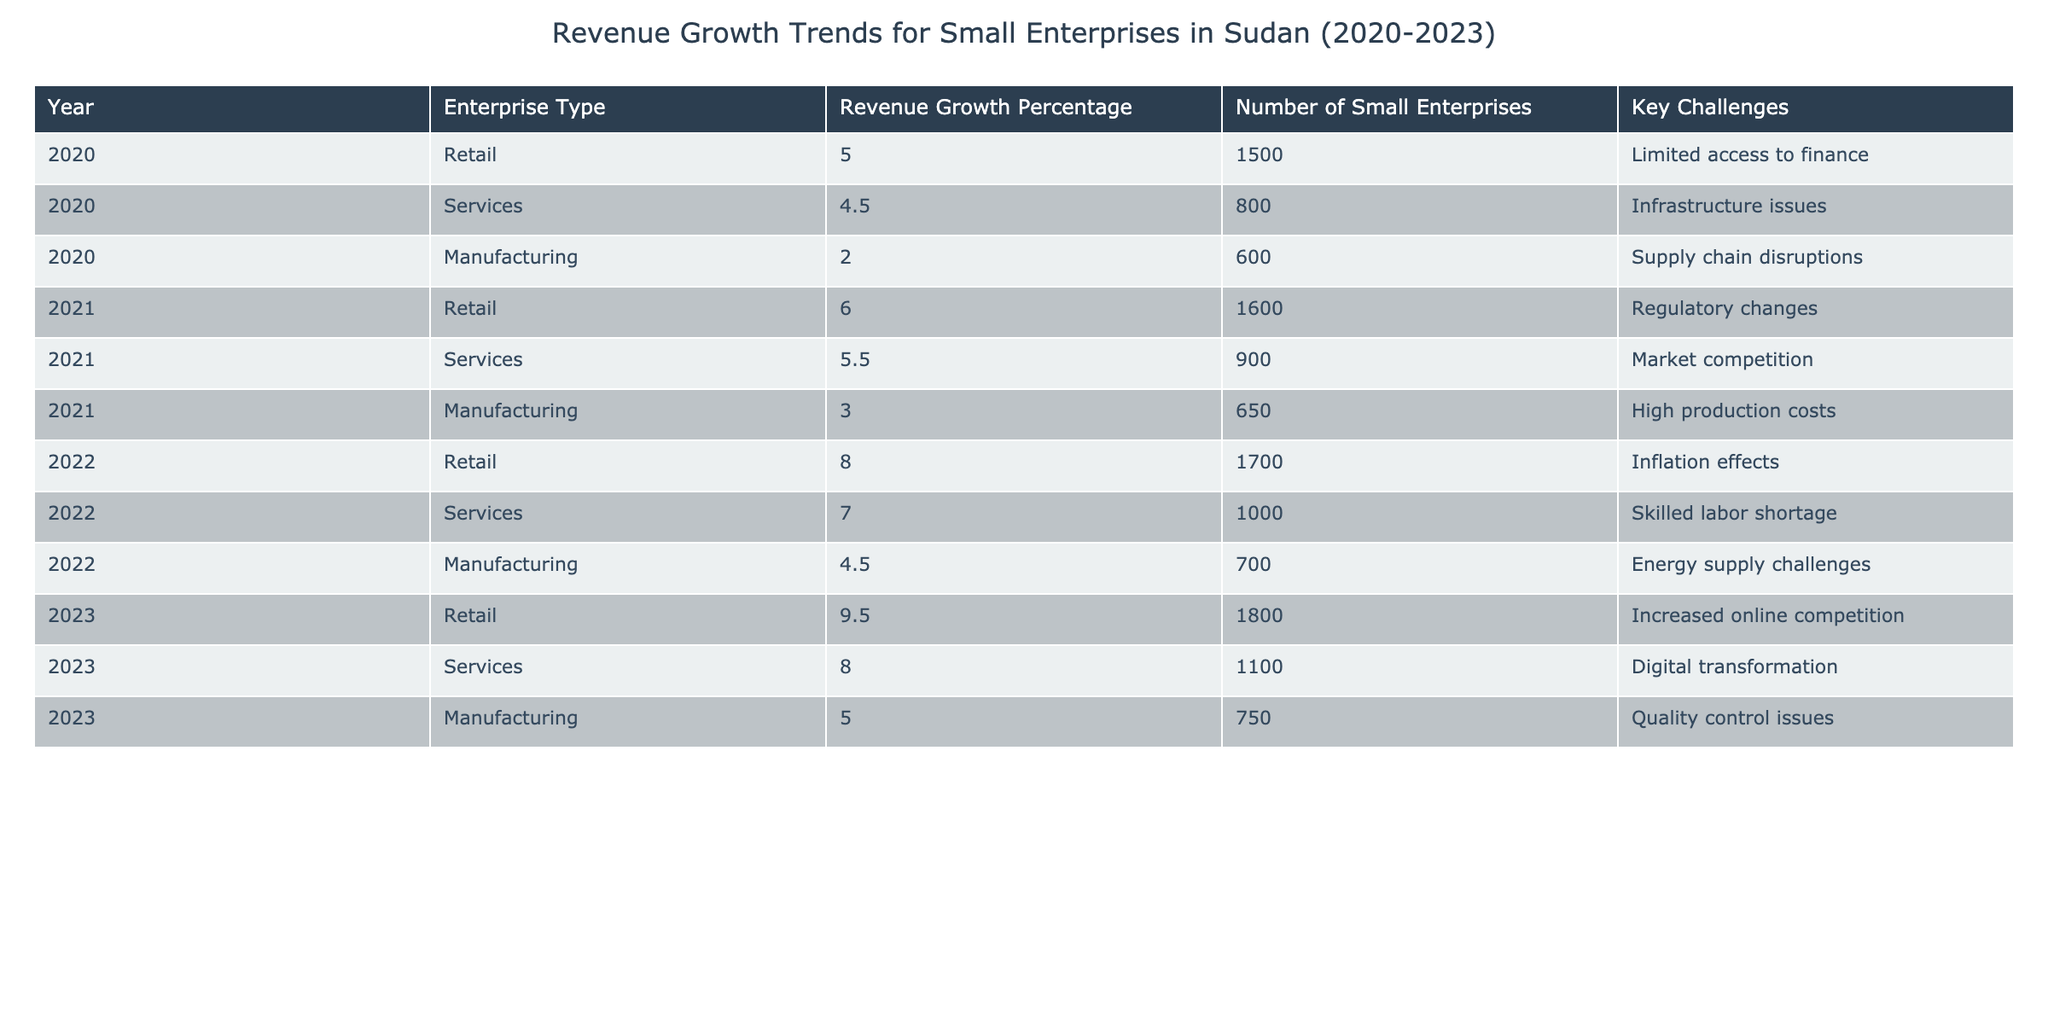What was the revenue growth percentage for the retail sector in 2022? Referring to the table, the revenue growth percentage for retail in 2022 is listed directly in the relevant row, which shows 8.0%.
Answer: 8.0% Which enterprise type had the highest revenue growth in 2023? Looking at the revenue growth percentages for each enterprise type in 2023, retail shows a growth of 9.5%, which is higher than services at 8.0% and manufacturing at 5.0%.
Answer: Retail What is the average revenue growth percentage for small enterprises from 2020 to 2023? The revenue growth percentages over the years are: 5.0, 6.0, 8.0, 9.5, 4.5, 5.5, 7.0, 8.0, 2.0, 3.0, 4.5, 5.0. Summing these gives 60.5. There are 12 data points, so the average is 60.5 / 12 = 5.04.
Answer: 5.04 In which year did the manufacturing sector see the highest revenue growth percentage? Checking the revenue growth percentages for manufacturing across the years, we find 2.0% in 2020, 3.0% in 2021, 4.5% in 2022, and 5.0% in 2023. The highest growth is 5.0% in 2023.
Answer: 2023 How many small enterprises were there in total across all sectors in 2021? The table lists the number of small enterprises for each sector in 2021: retail (1600), services (900), and manufacturing (650). Adding these gives 1600 + 900 + 650 = 3150.
Answer: 3150 Did services achieve a higher revenue growth than manufacturing in 2022? In 2022, services had a revenue growth of 7.0%, while manufacturing had 4.5%. Since 7.0% is greater than 4.5%, the statement is true.
Answer: Yes Which sector showed consistent revenue growth from 2020 to 2023? Analyzing the revenue growth percentages for each sector, retail shows continuous increases: 5.0% to 9.5%, services: 4.5% to 8.0%, and manufacturing: 2.0% to 5.0%. Each sector grew, but retail had the largest consistent growth.
Answer: Retail What was the key challenge for the services sector in 2023, and how does it differ from previous years? In 2023, the service sector faced digital transformation as a challenge, differing from earlier years where challenges included market competition in 2021 and skilled labor shortage in 2022.
Answer: Digital transformation Is there a trend indicating that the retail sector is growing faster than the manufacturing sector? By comparing the growth percentages, retail growth increased from 5.0% in 2020 to 9.5% in 2023, while manufacturing increased from 2.0% to 5.0%. Retail growth is consistently higher than manufacturing.
Answer: Yes 